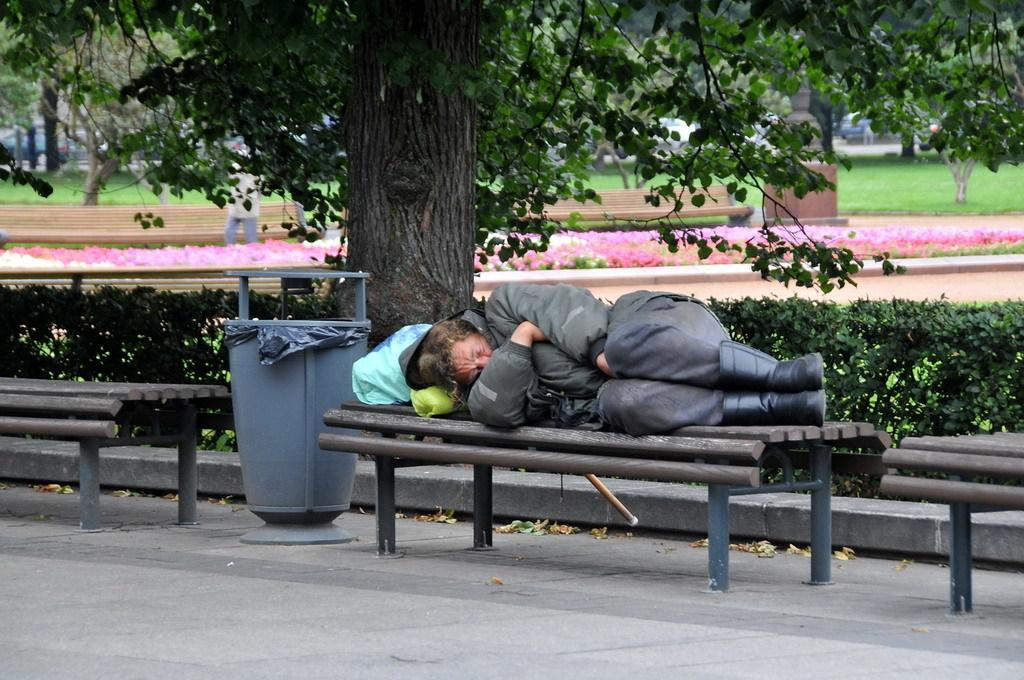What type of vegetation can be seen in the image? There are trees, flowers, and plants in the image. What type of surface is visible in the image? There is grass in the image. What type of furniture is present in the image? There are benches in the image. What type of receptacle is present in the image? There is a dustbin in the image. What is the person in the image wearing? The person is wearing a black jacket in the image. What is the person in the image doing? The person is sleeping on a bench in the image. Can you hear the person whistling in the image? There is no indication of whistling in the image, as the person is sleeping on a bench. What type of drink is the person holding in the image? There is no drink present in the image, and the person is sleeping on a bench. 